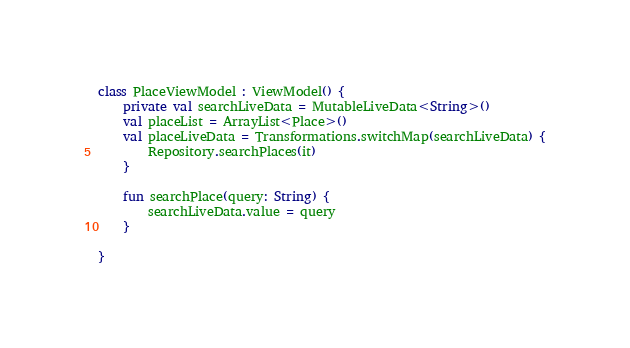<code> <loc_0><loc_0><loc_500><loc_500><_Kotlin_>
class PlaceViewModel : ViewModel() {
    private val searchLiveData = MutableLiveData<String>()
    val placeList = ArrayList<Place>()
    val placeLiveData = Transformations.switchMap(searchLiveData) {
        Repository.searchPlaces(it)
    }

    fun searchPlace(query: String) {
        searchLiveData.value = query
    }

}</code> 